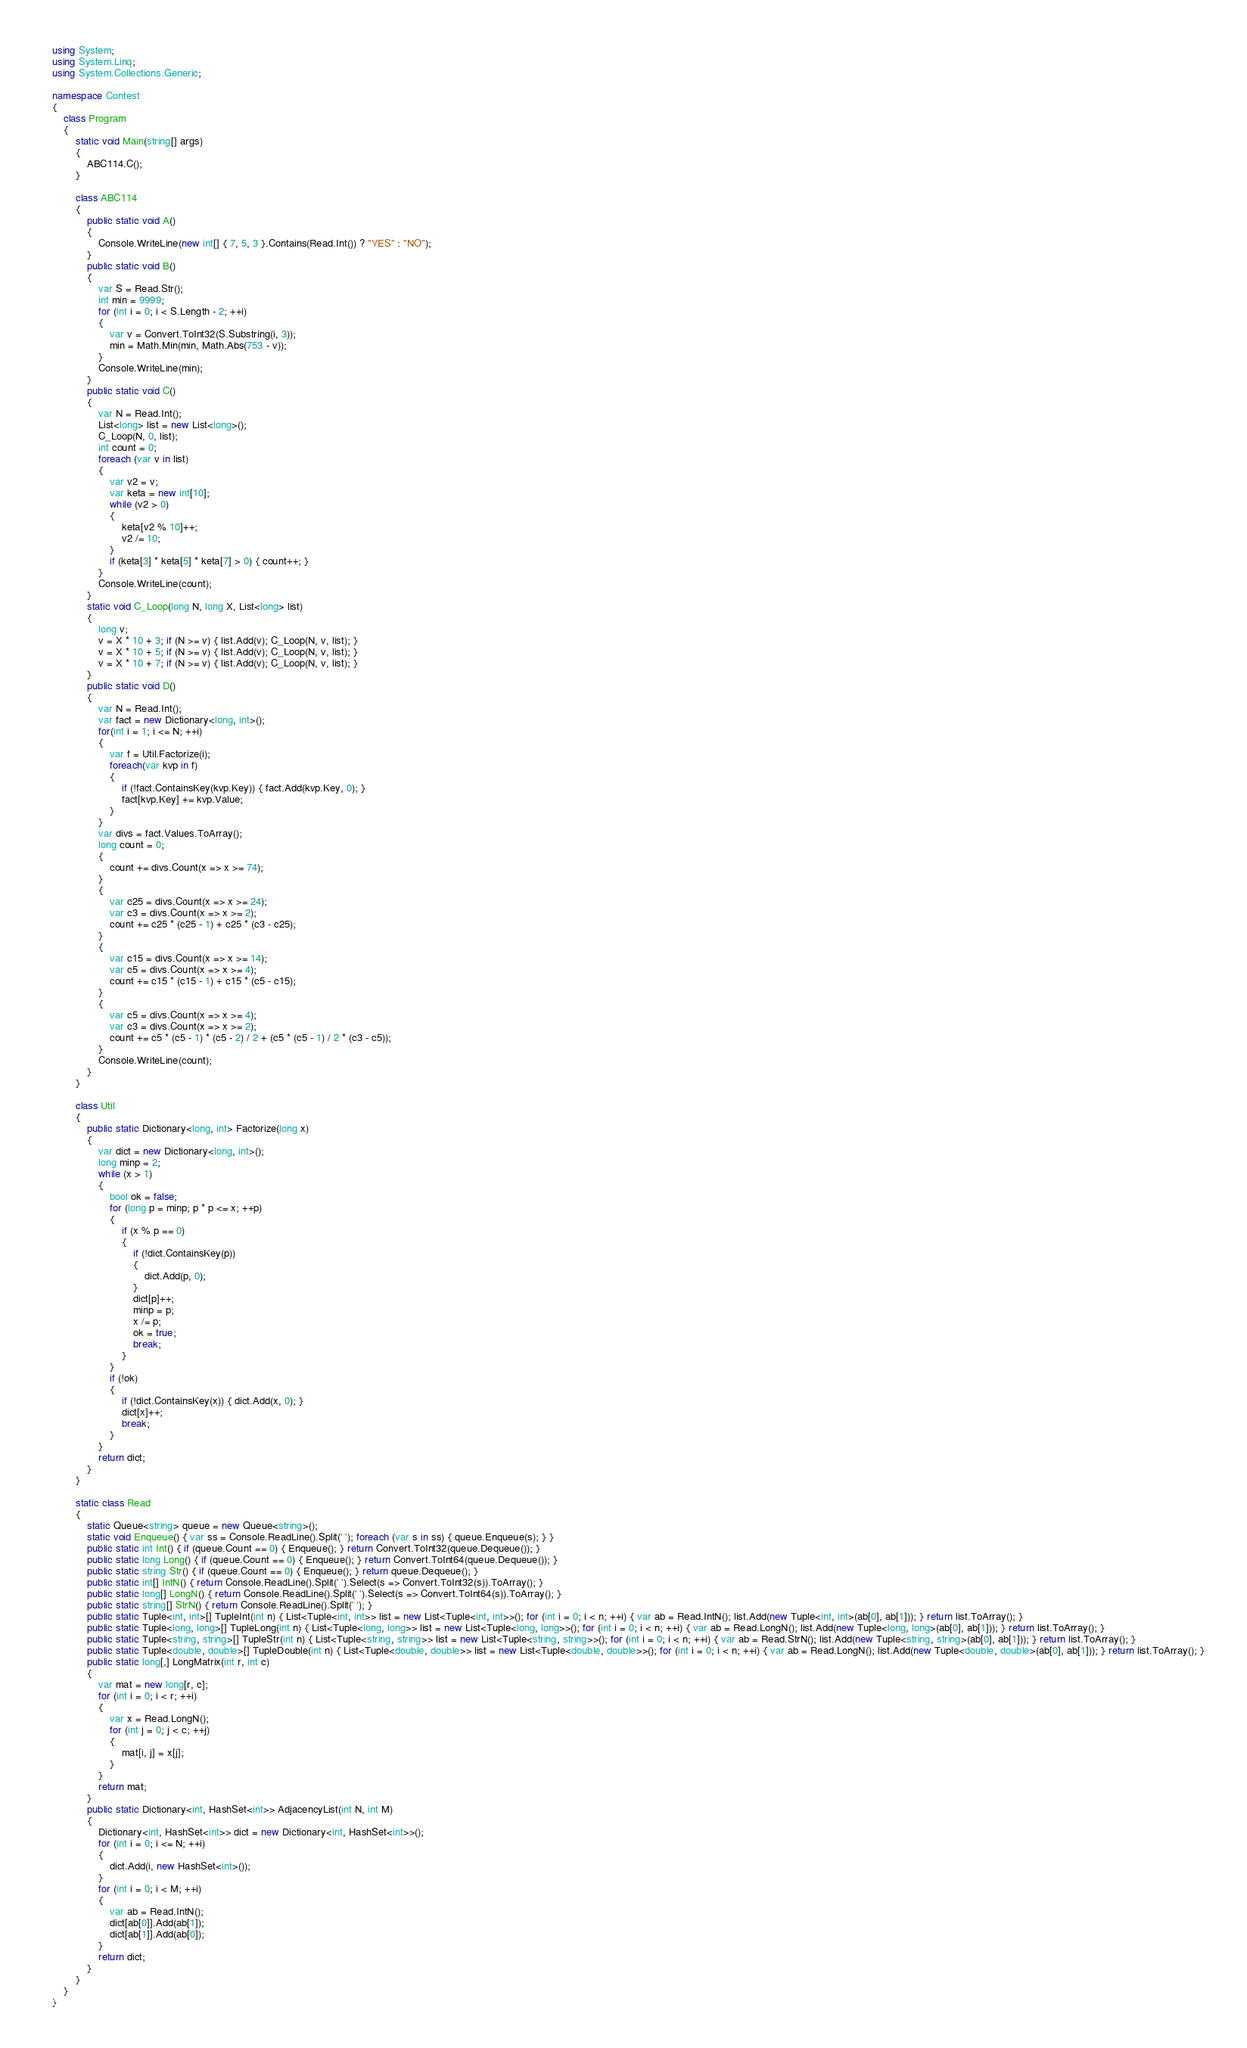<code> <loc_0><loc_0><loc_500><loc_500><_C#_>using System;
using System.Linq;
using System.Collections.Generic;

namespace Contest
{
    class Program
    {
        static void Main(string[] args)
        {
            ABC114.C();
        }
        
        class ABC114
        {
            public static void A()
            {
                Console.WriteLine(new int[] { 7, 5, 3 }.Contains(Read.Int()) ? "YES" : "NO");
            }
            public static void B()
            {
                var S = Read.Str();
                int min = 9999;
                for (int i = 0; i < S.Length - 2; ++i)
                {
                    var v = Convert.ToInt32(S.Substring(i, 3));
                    min = Math.Min(min, Math.Abs(753 - v));
                }
                Console.WriteLine(min);
            }
            public static void C()
            {
                var N = Read.Int();
                List<long> list = new List<long>();
                C_Loop(N, 0, list);
                int count = 0;
                foreach (var v in list)
                {
                    var v2 = v;
                    var keta = new int[10];
                    while (v2 > 0)
                    {
                        keta[v2 % 10]++;
                        v2 /= 10;
                    }
                    if (keta[3] * keta[5] * keta[7] > 0) { count++; }
                }
                Console.WriteLine(count);
            }
            static void C_Loop(long N, long X, List<long> list)
            {
                long v;
                v = X * 10 + 3; if (N >= v) { list.Add(v); C_Loop(N, v, list); }
                v = X * 10 + 5; if (N >= v) { list.Add(v); C_Loop(N, v, list); }
                v = X * 10 + 7; if (N >= v) { list.Add(v); C_Loop(N, v, list); }
            }
            public static void D()
            {
                var N = Read.Int();
                var fact = new Dictionary<long, int>();
                for(int i = 1; i <= N; ++i)
                {
                    var f = Util.Factorize(i);
                    foreach(var kvp in f)
                    {
                        if (!fact.ContainsKey(kvp.Key)) { fact.Add(kvp.Key, 0); }
                        fact[kvp.Key] += kvp.Value;
                    }
                }
                var divs = fact.Values.ToArray();
                long count = 0;
                {
                    count += divs.Count(x => x >= 74);
                }
                {
                    var c25 = divs.Count(x => x >= 24);
                    var c3 = divs.Count(x => x >= 2);
                    count += c25 * (c25 - 1) + c25 * (c3 - c25);
                }
                {
                    var c15 = divs.Count(x => x >= 14);
                    var c5 = divs.Count(x => x >= 4);
                    count += c15 * (c15 - 1) + c15 * (c5 - c15);
                }
                {
                    var c5 = divs.Count(x => x >= 4);
                    var c3 = divs.Count(x => x >= 2);
                    count += c5 * (c5 - 1) * (c5 - 2) / 2 + (c5 * (c5 - 1) / 2 * (c3 - c5));
                }
                Console.WriteLine(count);
            }
        }

        class Util
        {
            public static Dictionary<long, int> Factorize(long x)
            {
                var dict = new Dictionary<long, int>();
                long minp = 2;
                while (x > 1)
                {
                    bool ok = false;
                    for (long p = minp; p * p <= x; ++p)
                    {
                        if (x % p == 0)
                        {
                            if (!dict.ContainsKey(p))
                            {
                                dict.Add(p, 0);
                            }
                            dict[p]++;
                            minp = p;
                            x /= p;
                            ok = true;
                            break;
                        }
                    }
                    if (!ok)
                    {
                        if (!dict.ContainsKey(x)) { dict.Add(x, 0); }
                        dict[x]++;
                        break;
                    }
                }
                return dict;
            }
        }

        static class Read
        {
            static Queue<string> queue = new Queue<string>();
            static void Enqueue() { var ss = Console.ReadLine().Split(' '); foreach (var s in ss) { queue.Enqueue(s); } }
            public static int Int() { if (queue.Count == 0) { Enqueue(); } return Convert.ToInt32(queue.Dequeue()); }
            public static long Long() { if (queue.Count == 0) { Enqueue(); } return Convert.ToInt64(queue.Dequeue()); }
            public static string Str() { if (queue.Count == 0) { Enqueue(); } return queue.Dequeue(); }
            public static int[] IntN() { return Console.ReadLine().Split(' ').Select(s => Convert.ToInt32(s)).ToArray(); }
            public static long[] LongN() { return Console.ReadLine().Split(' ').Select(s => Convert.ToInt64(s)).ToArray(); }
            public static string[] StrN() { return Console.ReadLine().Split(' '); }
            public static Tuple<int, int>[] TupleInt(int n) { List<Tuple<int, int>> list = new List<Tuple<int, int>>(); for (int i = 0; i < n; ++i) { var ab = Read.IntN(); list.Add(new Tuple<int, int>(ab[0], ab[1])); } return list.ToArray(); }
            public static Tuple<long, long>[] TupleLong(int n) { List<Tuple<long, long>> list = new List<Tuple<long, long>>(); for (int i = 0; i < n; ++i) { var ab = Read.LongN(); list.Add(new Tuple<long, long>(ab[0], ab[1])); } return list.ToArray(); }
            public static Tuple<string, string>[] TupleStr(int n) { List<Tuple<string, string>> list = new List<Tuple<string, string>>(); for (int i = 0; i < n; ++i) { var ab = Read.StrN(); list.Add(new Tuple<string, string>(ab[0], ab[1])); } return list.ToArray(); }
            public static Tuple<double, double>[] TupleDouble(int n) { List<Tuple<double, double>> list = new List<Tuple<double, double>>(); for (int i = 0; i < n; ++i) { var ab = Read.LongN(); list.Add(new Tuple<double, double>(ab[0], ab[1])); } return list.ToArray(); }
            public static long[,] LongMatrix(int r, int c)
            {
                var mat = new long[r, c];
                for (int i = 0; i < r; ++i)
                {
                    var x = Read.LongN();
                    for (int j = 0; j < c; ++j)
                    {
                        mat[i, j] = x[j];
                    }
                }
                return mat;
            }
            public static Dictionary<int, HashSet<int>> AdjacencyList(int N, int M)
            {
                Dictionary<int, HashSet<int>> dict = new Dictionary<int, HashSet<int>>();
                for (int i = 0; i <= N; ++i)
                {
                    dict.Add(i, new HashSet<int>());
                }
                for (int i = 0; i < M; ++i)
                {
                    var ab = Read.IntN();
                    dict[ab[0]].Add(ab[1]);
                    dict[ab[1]].Add(ab[0]);
                }
                return dict;
            }
        }
    }
}
</code> 